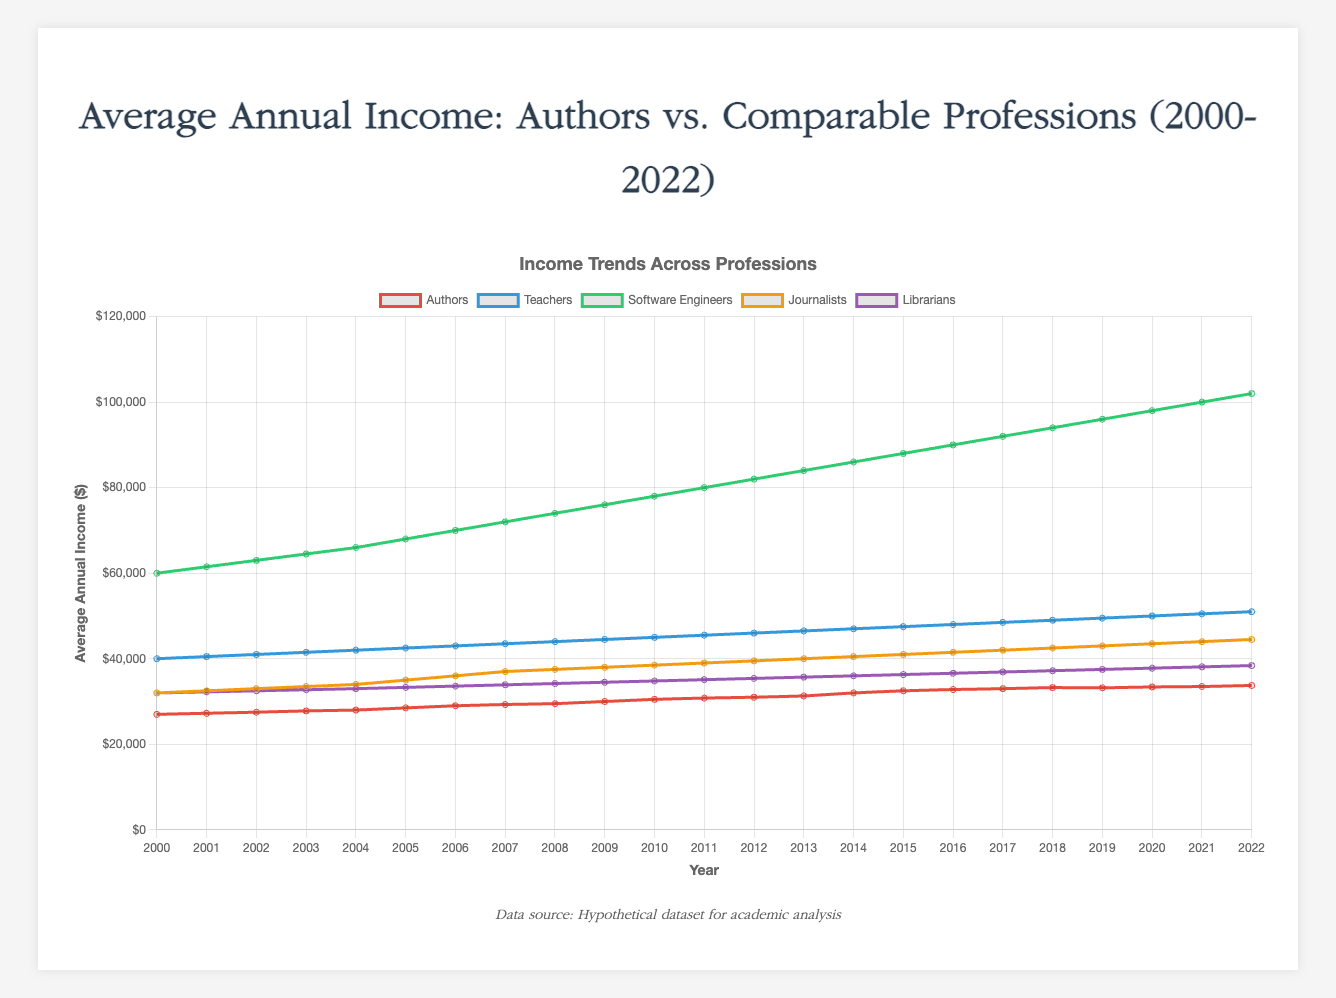What is the average annual income of authors in 2010? To find the average annual income of authors in 2010, refer to the data point for authors in 2010 on the chart.
Answer: $30,500 How does the income of authors in 2020 compare to that of teachers? Compare the data points for authors and teachers in 2020. Authors have an income of $33,400, while teachers have an income of $50,000.
Answer: Authors earn $16,600 less Which profession saw the highest increase in income from 2000 to 2022? Identify the initial income in 2000 and final income in 2022 for each profession, and calculate the increase: Authors ($33,750 - $27,000 = $6,750), Teachers ($51,000 - $40,000 = $11,000), Software Engineers ($102,000 - $60,000 = $42,000), Journalists ($44,500 - $32,000 = $12,500), and Librarians ($38,400 - $32,000 = $6,400). Software Engineers had the highest increase.
Answer: Software Engineers What is the income difference between journalists and librarians in 2015? Look at the data points for journalists and librarians in 2015. Journalists earn $41,000 and librarians earn $36,300. Subtract the librarian's income from the journalist's income.
Answer: $4,700 What is the average annual income for librarians over the two decades? Calculate the sum of all the annual incomes for librarians from 2000 to 2022 and then divide by the number of years. Total sum is $320,700 and there are 23 years.
Answer: $13,947.83 Considering the author’s income trend, what is the average rate of growth per year from 2000 to 2022? Evaluate the total increase in author's income from 2000 ($27,000) to 2022 ($33,750), which is $6,750, and divide by the number of years (22).
Answer: $306.82 per year In which year did the income for authors first cross $30,000? Look through the data points for authors to find the first instance where the income exceeds $30,000.
Answer: 2010 What is the income difference between the highest and lowest paid professions in 2022? Identify the highest paid profession (Software Engineers: $102,000) and the lowest paid profession (Authors: $33,750) in 2022, and calculate the difference.
Answer: $68,250 Which profession has the most stable income growth trend over the years? Assess the income growth trajectories of all professions and identify the one with the least fluctuations—most consistently increasing.
Answer: Librarians Did the income of authors ever exceed that of journalists from 2000 to 2022? Compare the annual incomes of authors and journalists each year to check if the authors' income ever exceeded the journalists' income.
Answer: No 